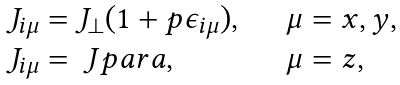Convert formula to latex. <formula><loc_0><loc_0><loc_500><loc_500>\begin{array} { l l } J _ { i \mu } = J _ { \perp } ( 1 + p \epsilon _ { i \mu } ) , \quad & \mu = x , y , \\ J _ { i \mu } = \ J p a r a , & \mu = z , \end{array}</formula> 